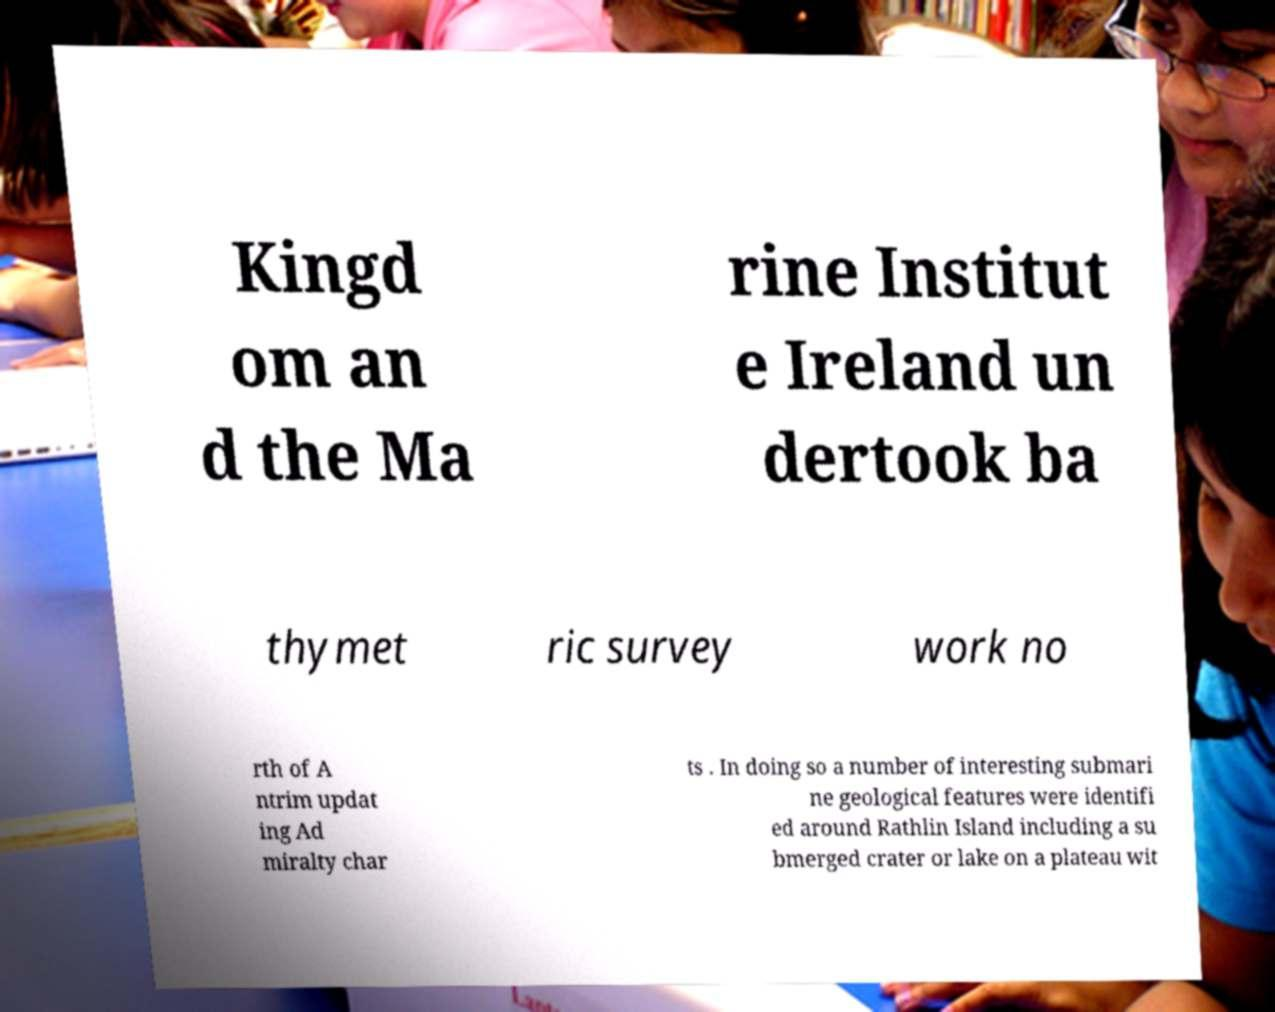Can you accurately transcribe the text from the provided image for me? Kingd om an d the Ma rine Institut e Ireland un dertook ba thymet ric survey work no rth of A ntrim updat ing Ad miralty char ts . In doing so a number of interesting submari ne geological features were identifi ed around Rathlin Island including a su bmerged crater or lake on a plateau wit 